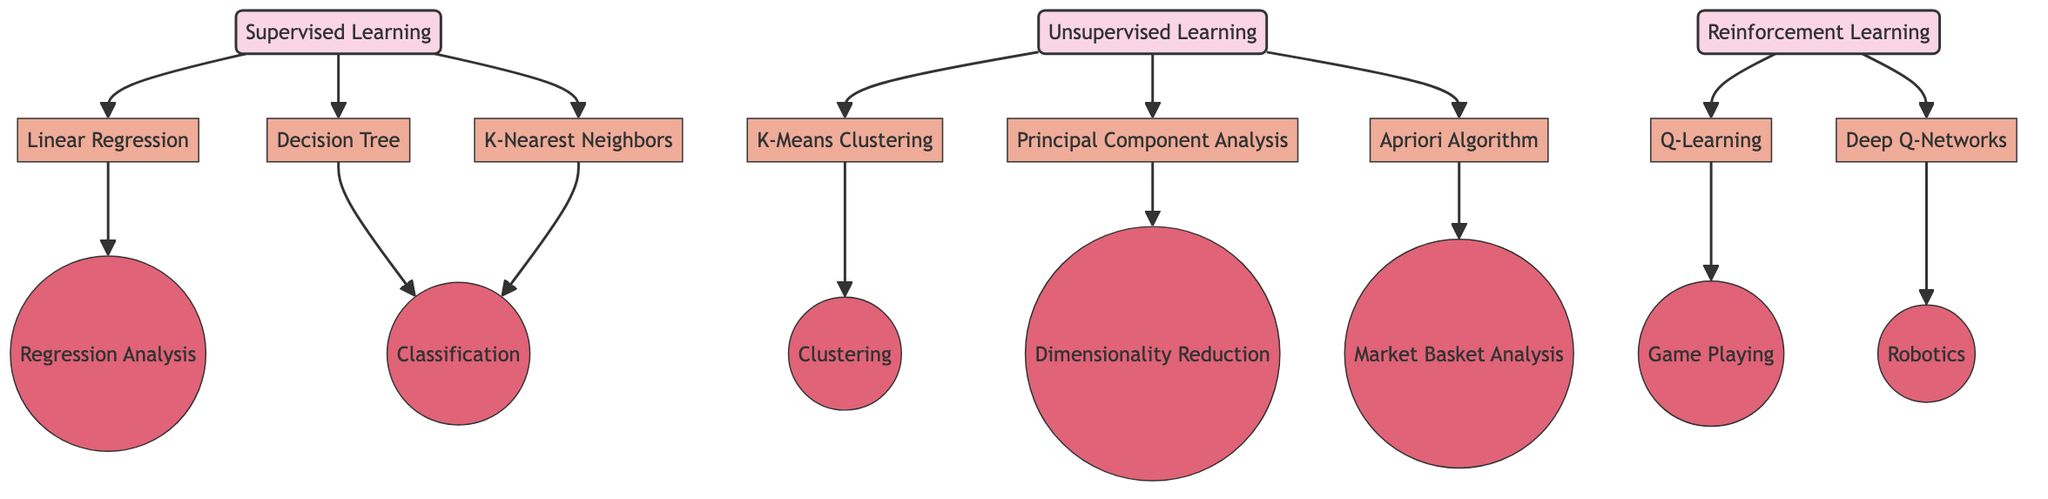What are the three main categories of machine learning models represented in the diagram? The diagram includes three main categories: Supervised Learning, Unsupervised Learning, and Reinforcement Learning. These categories are clearly labeled in the diagram and are distinct from each other.
Answer: Supervised Learning, Unsupervised Learning, Reinforcement Learning How many nodes are there in total? Counting all nodes, including categories, models, and applications, there are 19 nodes in total in the diagram. This consists of the three categories and sixteen models and applications.
Answer: 19 Which model is associated with Regression Analysis? The model associated with Regression Analysis is Linear Regression, as indicated by the arrows showing the connection from Linear Regression to Regression Analysis in the diagram.
Answer: Linear Regression What is the application of the Q-Learning model? According to the diagram, the application of the Q-Learning model is Game Playing, which is indicated by the direction of the arrow leading from Q-Learning to Game Playing.
Answer: Game Playing Which machine learning model is linked to both Classification and Clustering? Decision Tree and K-Nearest Neighbors are linked to Classification, while K-Means Clustering is linked to Clustering. Here, K-Nearest Neighbors is the only model that links to Classification but is not related to Clustering. Thus, the answer is that only K-Means Clustering is exclusively attached to Clustering.
Answer: K-Means Clustering How many models fall under Supervised Learning? The diagram shows three models under Supervised Learning, which are Linear Regression, Decision Tree, and K-Nearest Neighbors, that all originate from the Supervised Learning category.
Answer: Three Which model is associated with Dimensionality Reduction? The model linked to Dimensionality Reduction, as per the diagram, is Principal Component Analysis, denoted by an arrow leading from Principal Component Analysis to Dimensionality Reduction.
Answer: Principal Component Analysis How many total edges are in the diagram? By counting the directed connections between nodes, there are 16 total edges in the diagram, representing the relationships and flows from one node to another.
Answer: 16 What is the relationship between Deep Q-Networks and Robotics in this diagram? The diagram shows a direct connection from Deep Q-Networks to Robotics, indicating that Deep Q-Networks is a model related to the application of Robotics.
Answer: Application relationship Which three models are related to Unsupervised Learning? The models related to Unsupervised Learning are K-Means Clustering, Principal Component Analysis, and Apriori Algorithm, all of which branch from the Unsupervised Learning category in the diagram.
Answer: K-Means Clustering, Principal Component Analysis, Apriori Algorithm 